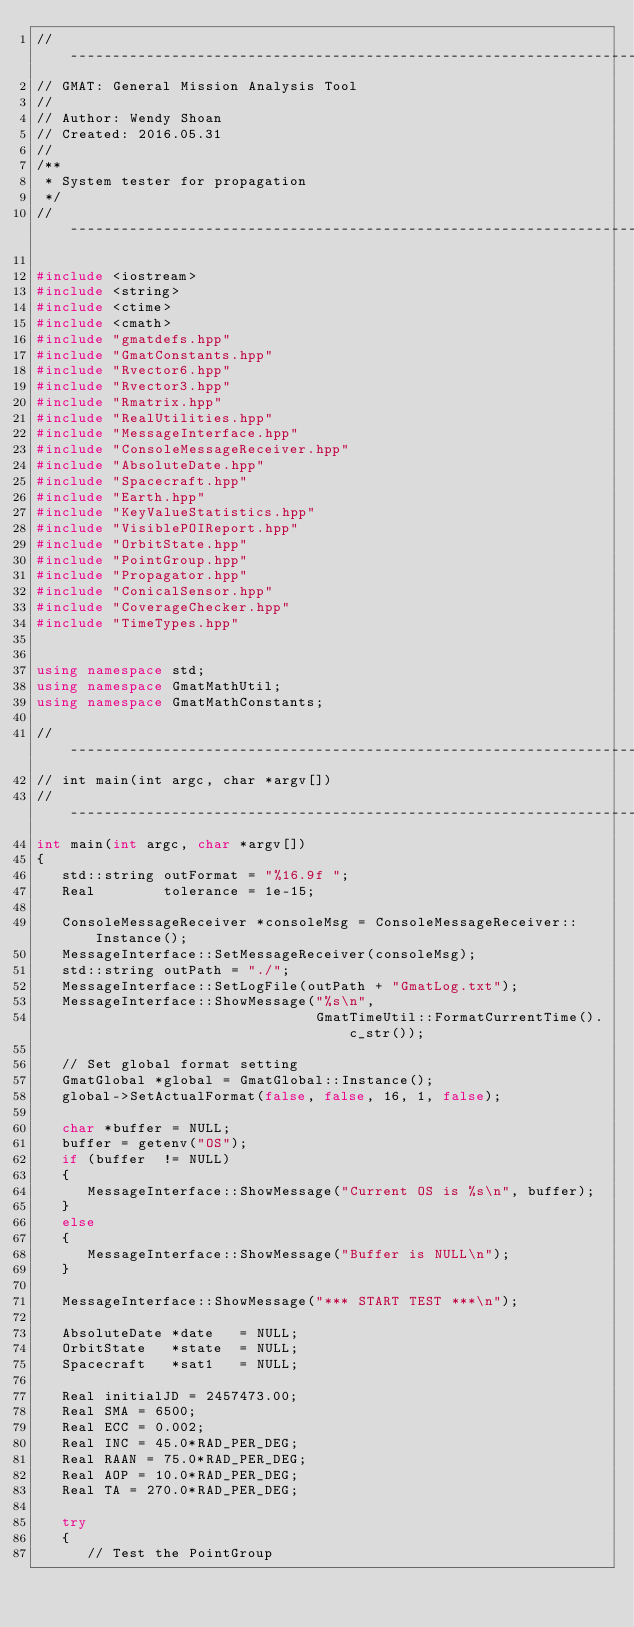<code> <loc_0><loc_0><loc_500><loc_500><_C++_>//------------------------------------------------------------------------------
// GMAT: General Mission Analysis Tool
//
// Author: Wendy Shoan
// Created: 2016.05.31
//
/**
 * System tester for propagation
 */
//------------------------------------------------------------------------------

#include <iostream>
#include <string>
#include <ctime>
#include <cmath>
#include "gmatdefs.hpp"
#include "GmatConstants.hpp"
#include "Rvector6.hpp"
#include "Rvector3.hpp"
#include "Rmatrix.hpp"
#include "RealUtilities.hpp"
#include "MessageInterface.hpp"
#include "ConsoleMessageReceiver.hpp"
#include "AbsoluteDate.hpp"
#include "Spacecraft.hpp"
#include "Earth.hpp"
#include "KeyValueStatistics.hpp"
#include "VisiblePOIReport.hpp"
#include "OrbitState.hpp"
#include "PointGroup.hpp"
#include "Propagator.hpp"
#include "ConicalSensor.hpp"
#include "CoverageChecker.hpp"
#include "TimeTypes.hpp"


using namespace std;
using namespace GmatMathUtil;
using namespace GmatMathConstants;

//------------------------------------------------------------------------------
// int main(int argc, char *argv[])
//------------------------------------------------------------------------------
int main(int argc, char *argv[])
{
   std::string outFormat = "%16.9f ";
   Real        tolerance = 1e-15;
   
   ConsoleMessageReceiver *consoleMsg = ConsoleMessageReceiver::Instance();
   MessageInterface::SetMessageReceiver(consoleMsg);
   std::string outPath = "./";
   MessageInterface::SetLogFile(outPath + "GmatLog.txt");
   MessageInterface::ShowMessage("%s\n",
                                 GmatTimeUtil::FormatCurrentTime().c_str());
   
   // Set global format setting
   GmatGlobal *global = GmatGlobal::Instance();
   global->SetActualFormat(false, false, 16, 1, false);
   
   char *buffer = NULL;
   buffer = getenv("OS");
   if (buffer  != NULL)
   {
      MessageInterface::ShowMessage("Current OS is %s\n", buffer);
   }
   else
   {
      MessageInterface::ShowMessage("Buffer is NULL\n");
   }
   
   MessageInterface::ShowMessage("*** START TEST ***\n");
   
   AbsoluteDate *date   = NULL;
   OrbitState   *state  = NULL;
   Spacecraft   *sat1   = NULL;

   Real initialJD = 2457473.00;
   Real SMA = 6500;
   Real ECC = 0.002;
   Real INC = 45.0*RAD_PER_DEG;
   Real RAAN = 75.0*RAD_PER_DEG;
   Real AOP = 10.0*RAD_PER_DEG;
   Real TA = 270.0*RAD_PER_DEG;
   
   try
   {
      // Test the PointGroup</code> 